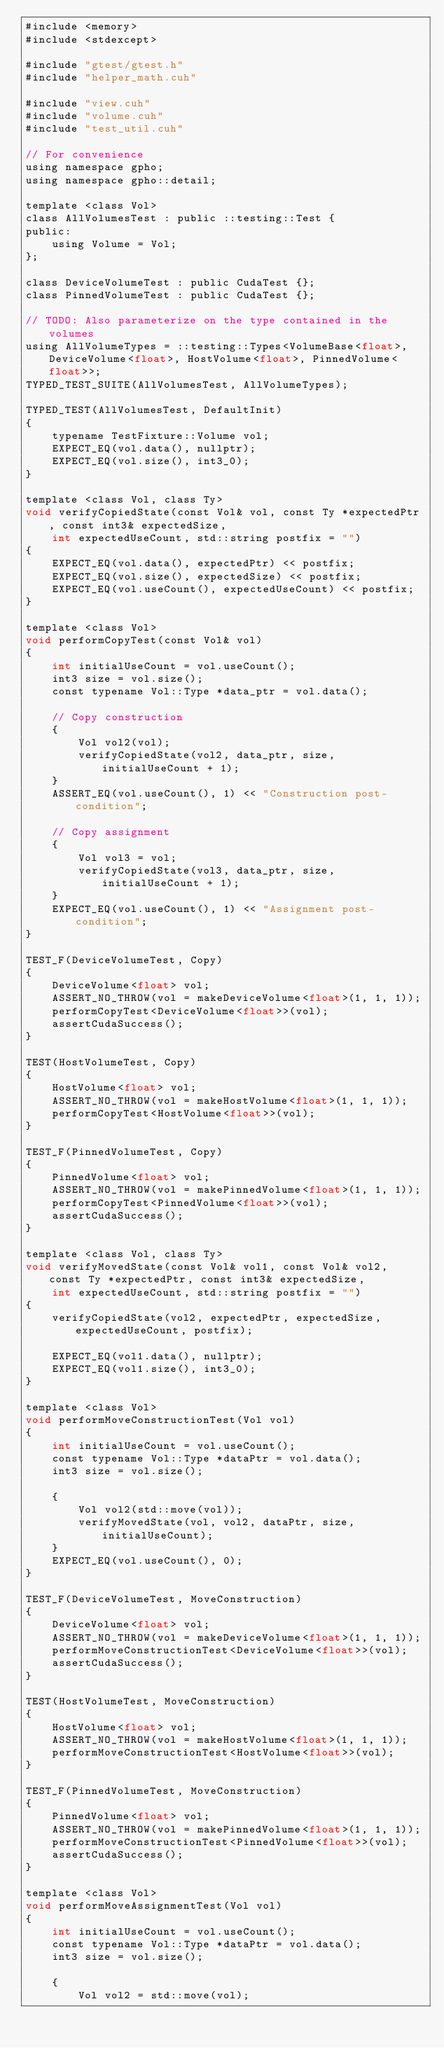Convert code to text. <code><loc_0><loc_0><loc_500><loc_500><_Cuda_>#include <memory>
#include <stdexcept>

#include "gtest/gtest.h"
#include "helper_math.cuh"

#include "view.cuh"
#include "volume.cuh"
#include "test_util.cuh"

// For convenience
using namespace gpho;
using namespace gpho::detail;

template <class Vol>
class AllVolumesTest : public ::testing::Test {
public:
    using Volume = Vol;
};

class DeviceVolumeTest : public CudaTest {};
class PinnedVolumeTest : public CudaTest {};

// TODO: Also parameterize on the type contained in the volumes
using AllVolumeTypes = ::testing::Types<VolumeBase<float>, DeviceVolume<float>, HostVolume<float>, PinnedVolume<float>>;
TYPED_TEST_SUITE(AllVolumesTest, AllVolumeTypes);

TYPED_TEST(AllVolumesTest, DefaultInit)
{
    typename TestFixture::Volume vol;
    EXPECT_EQ(vol.data(), nullptr);
    EXPECT_EQ(vol.size(), int3_0);
}

template <class Vol, class Ty>
void verifyCopiedState(const Vol& vol, const Ty *expectedPtr, const int3& expectedSize,
    int expectedUseCount, std::string postfix = "")
{
    EXPECT_EQ(vol.data(), expectedPtr) << postfix;
    EXPECT_EQ(vol.size(), expectedSize) << postfix;
    EXPECT_EQ(vol.useCount(), expectedUseCount) << postfix;
}

template <class Vol>
void performCopyTest(const Vol& vol)
{
    int initialUseCount = vol.useCount();
    int3 size = vol.size();
    const typename Vol::Type *data_ptr = vol.data();

    // Copy construction
    {
        Vol vol2(vol);
        verifyCopiedState(vol2, data_ptr, size, initialUseCount + 1);
    }
    ASSERT_EQ(vol.useCount(), 1) << "Construction post-condition";

    // Copy assignment
    {
        Vol vol3 = vol;
        verifyCopiedState(vol3, data_ptr, size, initialUseCount + 1);
    }
    EXPECT_EQ(vol.useCount(), 1) << "Assignment post-condition";
}

TEST_F(DeviceVolumeTest, Copy)
{
    DeviceVolume<float> vol;
    ASSERT_NO_THROW(vol = makeDeviceVolume<float>(1, 1, 1));
    performCopyTest<DeviceVolume<float>>(vol);
    assertCudaSuccess();
}

TEST(HostVolumeTest, Copy)
{
    HostVolume<float> vol;
    ASSERT_NO_THROW(vol = makeHostVolume<float>(1, 1, 1));
    performCopyTest<HostVolume<float>>(vol);
}

TEST_F(PinnedVolumeTest, Copy)
{
    PinnedVolume<float> vol;
    ASSERT_NO_THROW(vol = makePinnedVolume<float>(1, 1, 1));
    performCopyTest<PinnedVolume<float>>(vol);
    assertCudaSuccess();
}

template <class Vol, class Ty>
void verifyMovedState(const Vol& vol1, const Vol& vol2, const Ty *expectedPtr, const int3& expectedSize,
    int expectedUseCount, std::string postfix = "")
{
    verifyCopiedState(vol2, expectedPtr, expectedSize, expectedUseCount, postfix);

    EXPECT_EQ(vol1.data(), nullptr);
    EXPECT_EQ(vol1.size(), int3_0);
}

template <class Vol>
void performMoveConstructionTest(Vol vol)
{
    int initialUseCount = vol.useCount();
    const typename Vol::Type *dataPtr = vol.data();
    int3 size = vol.size();

    {
        Vol vol2(std::move(vol));
        verifyMovedState(vol, vol2, dataPtr, size, initialUseCount);
    }
    EXPECT_EQ(vol.useCount(), 0);
}

TEST_F(DeviceVolumeTest, MoveConstruction)
{
    DeviceVolume<float> vol;
    ASSERT_NO_THROW(vol = makeDeviceVolume<float>(1, 1, 1));
    performMoveConstructionTest<DeviceVolume<float>>(vol);
    assertCudaSuccess();
}

TEST(HostVolumeTest, MoveConstruction)
{
    HostVolume<float> vol;
    ASSERT_NO_THROW(vol = makeHostVolume<float>(1, 1, 1));
    performMoveConstructionTest<HostVolume<float>>(vol);
}

TEST_F(PinnedVolumeTest, MoveConstruction)
{
    PinnedVolume<float> vol;
    ASSERT_NO_THROW(vol = makePinnedVolume<float>(1, 1, 1));
    performMoveConstructionTest<PinnedVolume<float>>(vol);
    assertCudaSuccess();
}

template <class Vol>
void performMoveAssignmentTest(Vol vol)
{
    int initialUseCount = vol.useCount();
    const typename Vol::Type *dataPtr = vol.data();
    int3 size = vol.size();

    {
        Vol vol2 = std::move(vol);</code> 